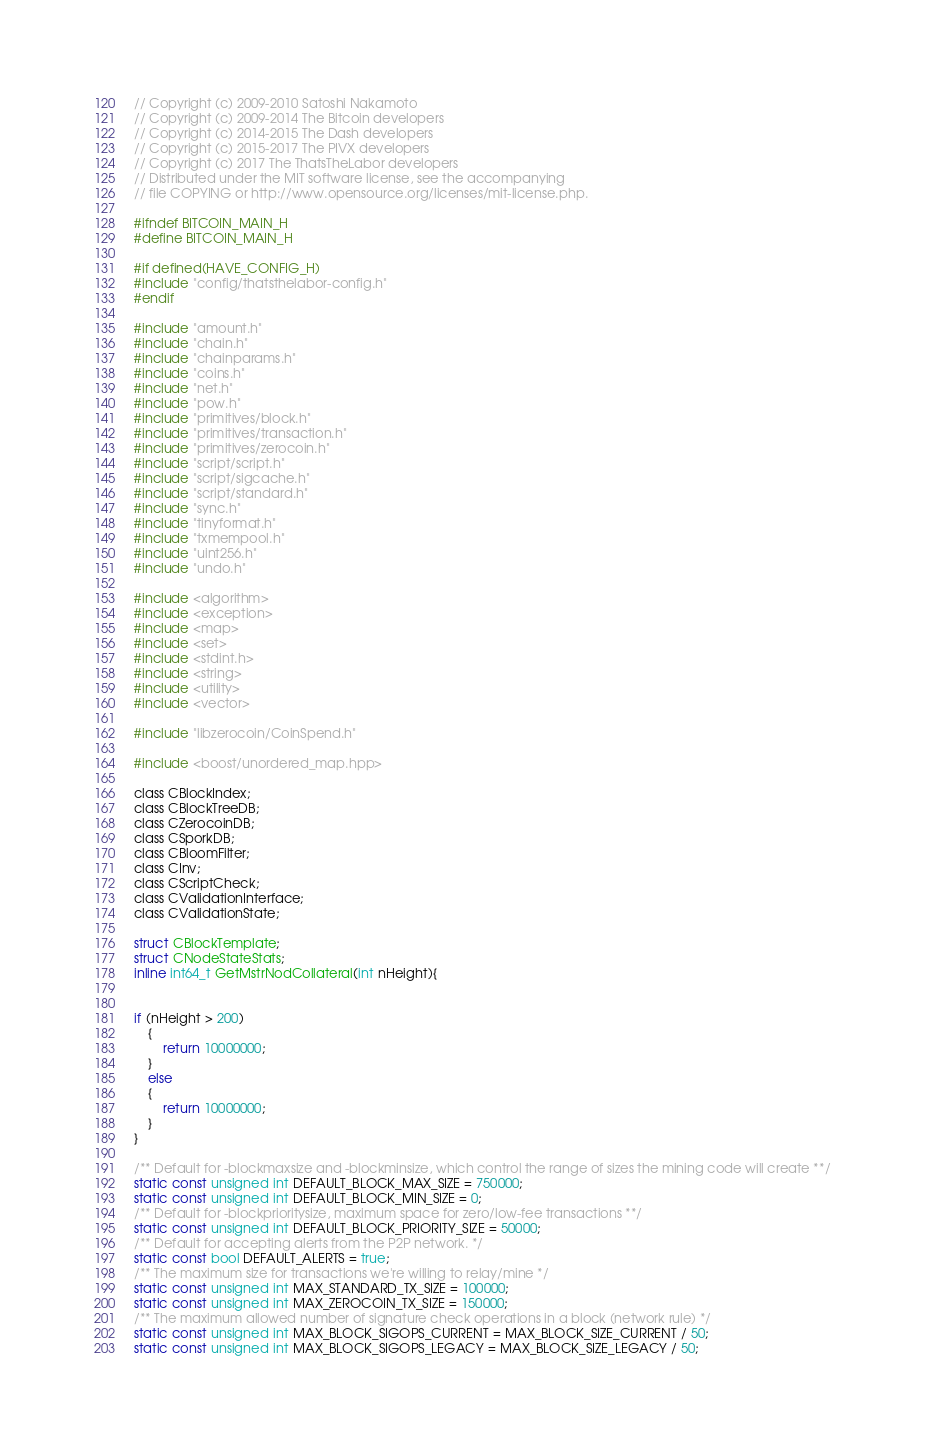Convert code to text. <code><loc_0><loc_0><loc_500><loc_500><_C_>// Copyright (c) 2009-2010 Satoshi Nakamoto
// Copyright (c) 2009-2014 The Bitcoin developers
// Copyright (c) 2014-2015 The Dash developers
// Copyright (c) 2015-2017 The PIVX developers
// Copyright (c) 2017 The ThatsTheLabor developers
// Distributed under the MIT software license, see the accompanying
// file COPYING or http://www.opensource.org/licenses/mit-license.php.

#ifndef BITCOIN_MAIN_H
#define BITCOIN_MAIN_H

#if defined(HAVE_CONFIG_H)
#include "config/thatsthelabor-config.h"
#endif

#include "amount.h"
#include "chain.h"
#include "chainparams.h"
#include "coins.h"
#include "net.h"
#include "pow.h"
#include "primitives/block.h"
#include "primitives/transaction.h"
#include "primitives/zerocoin.h"
#include "script/script.h"
#include "script/sigcache.h"
#include "script/standard.h"
#include "sync.h"
#include "tinyformat.h"
#include "txmempool.h"
#include "uint256.h"
#include "undo.h"

#include <algorithm>
#include <exception>
#include <map>
#include <set>
#include <stdint.h>
#include <string>
#include <utility>
#include <vector>

#include "libzerocoin/CoinSpend.h"

#include <boost/unordered_map.hpp>

class CBlockIndex;
class CBlockTreeDB;
class CZerocoinDB;
class CSporkDB;
class CBloomFilter;
class CInv;
class CScriptCheck;
class CValidationInterface;
class CValidationState;

struct CBlockTemplate;
struct CNodeStateStats;
inline int64_t GetMstrNodCollateral(int nHeight){


if (nHeight > 200)
	{
		return 10000000;
	}
	else
	{
		return 10000000;
	}
}

/** Default for -blockmaxsize and -blockminsize, which control the range of sizes the mining code will create **/
static const unsigned int DEFAULT_BLOCK_MAX_SIZE = 750000;
static const unsigned int DEFAULT_BLOCK_MIN_SIZE = 0;
/** Default for -blockprioritysize, maximum space for zero/low-fee transactions **/
static const unsigned int DEFAULT_BLOCK_PRIORITY_SIZE = 50000;
/** Default for accepting alerts from the P2P network. */
static const bool DEFAULT_ALERTS = true;
/** The maximum size for transactions we're willing to relay/mine */
static const unsigned int MAX_STANDARD_TX_SIZE = 100000;
static const unsigned int MAX_ZEROCOIN_TX_SIZE = 150000;
/** The maximum allowed number of signature check operations in a block (network rule) */
static const unsigned int MAX_BLOCK_SIGOPS_CURRENT = MAX_BLOCK_SIZE_CURRENT / 50;
static const unsigned int MAX_BLOCK_SIGOPS_LEGACY = MAX_BLOCK_SIZE_LEGACY / 50;</code> 